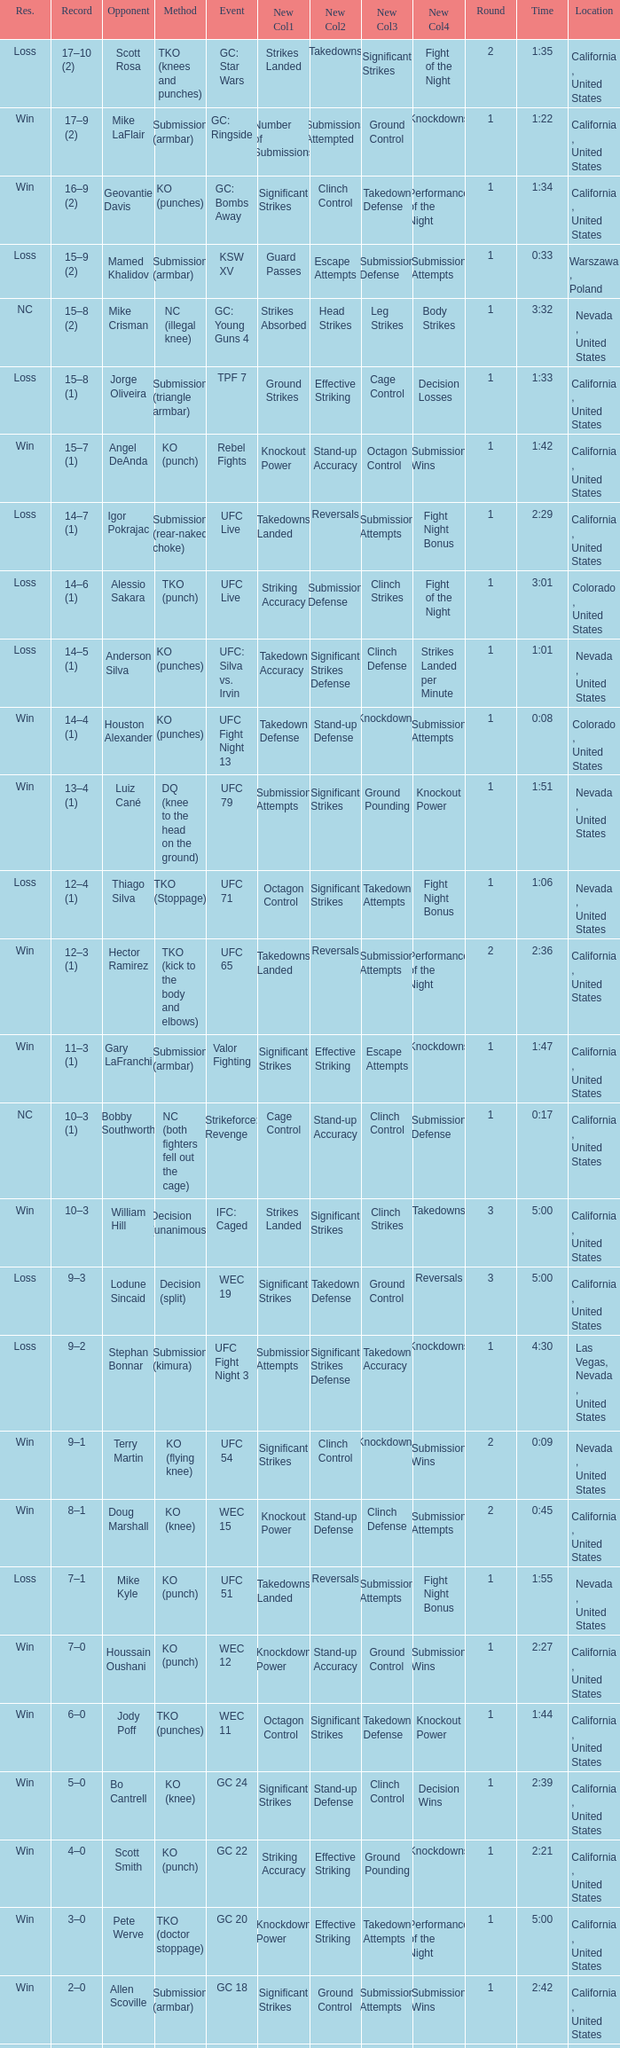What is the method where there is a loss with time 5:00? Decision (split). I'm looking to parse the entire table for insights. Could you assist me with that? {'header': ['Res.', 'Record', 'Opponent', 'Method', 'Event', 'New Col1', 'New Col2', 'New Col3', 'New Col4', 'Round', 'Time', 'Location'], 'rows': [['Loss', '17–10 (2)', 'Scott Rosa', 'TKO (knees and punches)', 'GC: Star Wars', 'Strikes Landed', 'Takedowns', 'Significant Strikes', 'Fight of the Night', '2', '1:35', 'California , United States'], ['Win', '17–9 (2)', 'Mike LaFlair', 'Submission (armbar)', 'GC: Ringside', 'Number of Submissions', 'Submissions Attempted', 'Ground Control', 'Knockdowns', '1', '1:22', 'California , United States'], ['Win', '16–9 (2)', 'Geovantie Davis', 'KO (punches)', 'GC: Bombs Away', 'Significant Strikes', 'Clinch Control', 'Takedown Defense', 'Performance of the Night', '1', '1:34', 'California , United States'], ['Loss', '15–9 (2)', 'Mamed Khalidov', 'Submission (armbar)', 'KSW XV', 'Guard Passes', 'Escape Attempts', 'Submission Defense', 'Submission Attempts', '1', '0:33', 'Warszawa , Poland'], ['NC', '15–8 (2)', 'Mike Crisman', 'NC (illegal knee)', 'GC: Young Guns 4', 'Strikes Absorbed', 'Head Strikes', 'Leg Strikes', 'Body Strikes', '1', '3:32', 'Nevada , United States'], ['Loss', '15–8 (1)', 'Jorge Oliveira', 'Submission (triangle armbar)', 'TPF 7', 'Ground Strikes', 'Effective Striking', 'Cage Control', 'Decision Losses', '1', '1:33', 'California , United States'], ['Win', '15–7 (1)', 'Angel DeAnda', 'KO (punch)', 'Rebel Fights', 'Knockout Power', 'Stand-up Accuracy', 'Octagon Control', 'Submission Wins', '1', '1:42', 'California , United States'], ['Loss', '14–7 (1)', 'Igor Pokrajac', 'Submission (rear-naked choke)', 'UFC Live', 'Takedowns Landed', 'Reversals', 'Submission Attempts', 'Fight Night Bonus', '1', '2:29', 'California , United States'], ['Loss', '14–6 (1)', 'Alessio Sakara', 'TKO (punch)', 'UFC Live', 'Striking Accuracy', 'Submission Defense', 'Clinch Strikes', 'Fight of the Night', '1', '3:01', 'Colorado , United States'], ['Loss', '14–5 (1)', 'Anderson Silva', 'KO (punches)', 'UFC: Silva vs. Irvin', 'Takedown Accuracy', 'Significant Strikes Defense', 'Clinch Defense', 'Strikes Landed per Minute', '1', '1:01', 'Nevada , United States'], ['Win', '14–4 (1)', 'Houston Alexander', 'KO (punches)', 'UFC Fight Night 13', 'Takedown Defense', 'Stand-up Defense', 'Knockdowns', 'Submission Attempts', '1', '0:08', 'Colorado , United States'], ['Win', '13–4 (1)', 'Luiz Cané', 'DQ (knee to the head on the ground)', 'UFC 79', 'Submission Attempts', 'Significant Strikes', 'Ground Pounding', 'Knockout Power', '1', '1:51', 'Nevada , United States'], ['Loss', '12–4 (1)', 'Thiago Silva', 'TKO (Stoppage)', 'UFC 71', 'Octagon Control', 'Significant Strikes', 'Takedown Attempts', 'Fight Night Bonus', '1', '1:06', 'Nevada , United States'], ['Win', '12–3 (1)', 'Hector Ramirez', 'TKO (kick to the body and elbows)', 'UFC 65', 'Takedowns Landed', 'Reversals', 'Submission Attempts', 'Performance of the Night', '2', '2:36', 'California , United States'], ['Win', '11–3 (1)', 'Gary LaFranchi', 'Submission (armbar)', 'Valor Fighting', 'Significant Strikes', 'Effective Striking', 'Escape Attempts', 'Knockdowns', '1', '1:47', 'California , United States'], ['NC', '10–3 (1)', 'Bobby Southworth', 'NC (both fighters fell out the cage)', 'Strikeforce: Revenge', 'Cage Control', 'Stand-up Accuracy', 'Clinch Control', 'Submission Defense', '1', '0:17', 'California , United States'], ['Win', '10–3', 'William Hill', 'Decision (unanimous)', 'IFC: Caged', 'Strikes Landed', 'Significant Strikes', 'Clinch Strikes', 'Takedowns', '3', '5:00', 'California , United States'], ['Loss', '9–3', 'Lodune Sincaid', 'Decision (split)', 'WEC 19', 'Significant Strikes', 'Takedown Defense', 'Ground Control', 'Reversals', '3', '5:00', 'California , United States'], ['Loss', '9–2', 'Stephan Bonnar', 'Submission (kimura)', 'UFC Fight Night 3', 'Submission Attempts', 'Significant Strikes Defense', 'Takedown Accuracy', 'Knockdowns', '1', '4:30', 'Las Vegas, Nevada , United States'], ['Win', '9–1', 'Terry Martin', 'KO (flying knee)', 'UFC 54', 'Significant Strikes', 'Clinch Control', 'Knockdowns', 'Submission Wins', '2', '0:09', 'Nevada , United States'], ['Win', '8–1', 'Doug Marshall', 'KO (knee)', 'WEC 15', 'Knockout Power', 'Stand-up Defense', 'Clinch Defense', 'Submission Attempts', '2', '0:45', 'California , United States'], ['Loss', '7–1', 'Mike Kyle', 'KO (punch)', 'UFC 51', 'Takedowns Landed', 'Reversals', 'Submission Attempts', 'Fight Night Bonus', '1', '1:55', 'Nevada , United States'], ['Win', '7–0', 'Houssain Oushani', 'KO (punch)', 'WEC 12', 'Knockdown Power', 'Stand-up Accuracy', 'Ground Control', 'Submission Wins', '1', '2:27', 'California , United States'], ['Win', '6–0', 'Jody Poff', 'TKO (punches)', 'WEC 11', 'Octagon Control', 'Significant Strikes', 'Takedown Defense', 'Knockout Power', '1', '1:44', 'California , United States'], ['Win', '5–0', 'Bo Cantrell', 'KO (knee)', 'GC 24', 'Significant Strikes', 'Stand-up Defense', 'Clinch Control', 'Decision Wins', '1', '2:39', 'California , United States'], ['Win', '4–0', 'Scott Smith', 'KO (punch)', 'GC 22', 'Striking Accuracy', 'Effective Striking', 'Ground Pounding', 'Knockdowns', '1', '2:21', 'California , United States'], ['Win', '3–0', 'Pete Werve', 'TKO (doctor stoppage)', 'GC 20', 'Knockdown Power', 'Effective Striking', 'Takedown Attempts', 'Performance of the Night', '1', '5:00', 'California , United States'], ['Win', '2–0', 'Allen Scoville', 'Submission (armbar)', 'GC 18', 'Significant Strikes', 'Ground Control', 'Submission Attempts', 'Submission Wins', '1', '2:42', 'California , United States'], ['Win', '1–0', 'Bo Cantrell', 'KO (knee and punches)', 'GC 16', 'Knockdown Power', 'Stand-up Accuracy', 'Octagon Control', 'Ground Pounding', '1', '2:54', 'California , United States']]} 